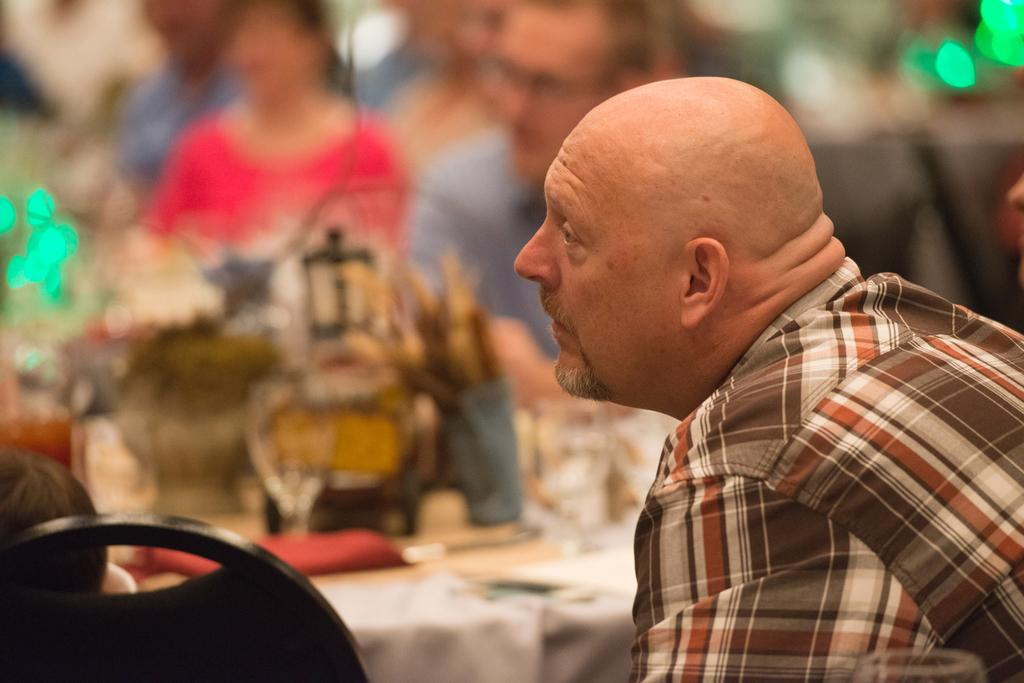Who or what is present in the image? There is a person in the image. What direction is the person looking in? The person is looking towards the left. What piece of furniture can be seen in the image? There is a chair in the image. What type of illumination is present in the image? There are lights in the image. What is the price of the stick in the image? There is no stick present in the image, so it is not possible to determine its price. What type of oatmeal is being served in the image? There is no oatmeal present in the image, so it is not possible to determine what type of oatmeal might be served. 